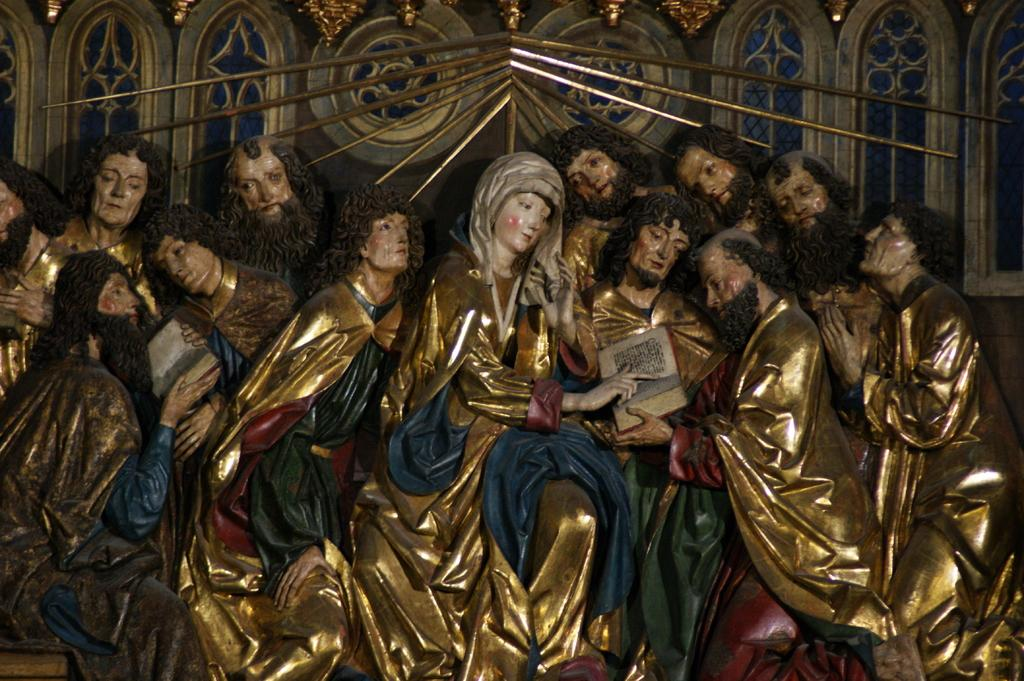What type of art is present in the image? There are sculptures in the image. Where are the sculptures located in relation to other elements in the image? The sculptures are in front of a wall. What scientific force is being applied to the sculptures in the image? There is no scientific force being applied to the sculptures in the image; they are stationary and not interacting with any forces. 